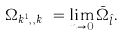<formula> <loc_0><loc_0><loc_500><loc_500>\Omega _ { { k } ^ { 1 } , \cdots , { k } ^ { g } } = \lim _ { n \to 0 } \bar { \Omega } _ { \hat { l } } .</formula> 